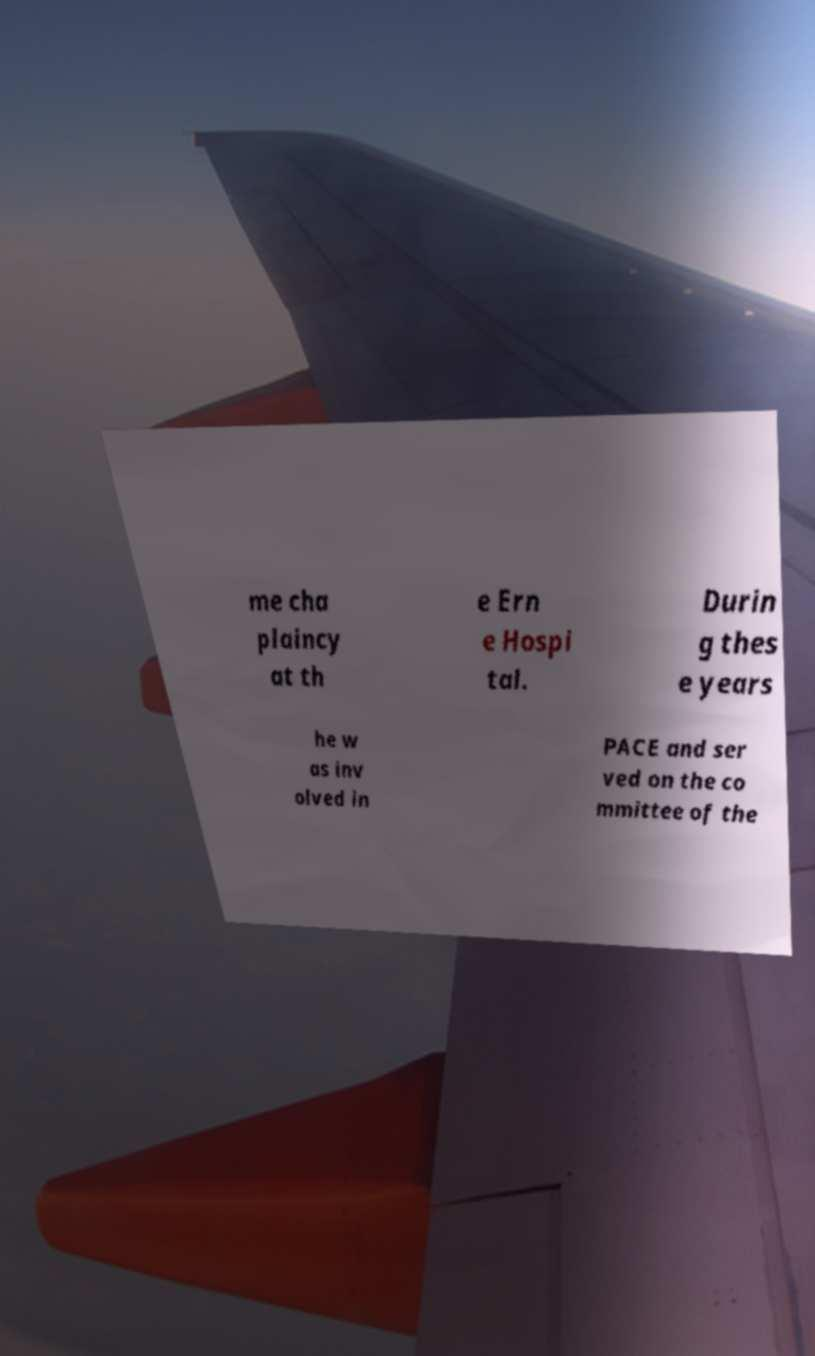For documentation purposes, I need the text within this image transcribed. Could you provide that? me cha plaincy at th e Ern e Hospi tal. Durin g thes e years he w as inv olved in PACE and ser ved on the co mmittee of the 